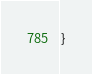<code> <loc_0><loc_0><loc_500><loc_500><_C++_>
}
</code> 